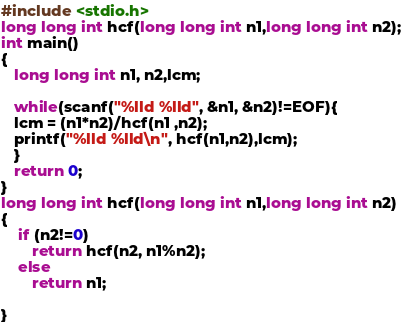Convert code to text. <code><loc_0><loc_0><loc_500><loc_500><_C_>#include <stdio.h>
long long int hcf(long long int n1,long long int n2);
int main()
{
   long long int n1, n2,lcm;

   while(scanf("%lld %lld", &n1, &n2)!=EOF){
   lcm = (n1*n2)/hcf(n1 ,n2);
   printf("%lld %lld\n", hcf(n1,n2),lcm);
   }
   return 0;
}
long long int hcf(long long int n1,long long int n2)
{
    if (n2!=0)
       return hcf(n2, n1%n2);
    else
       return n1;

}</code> 